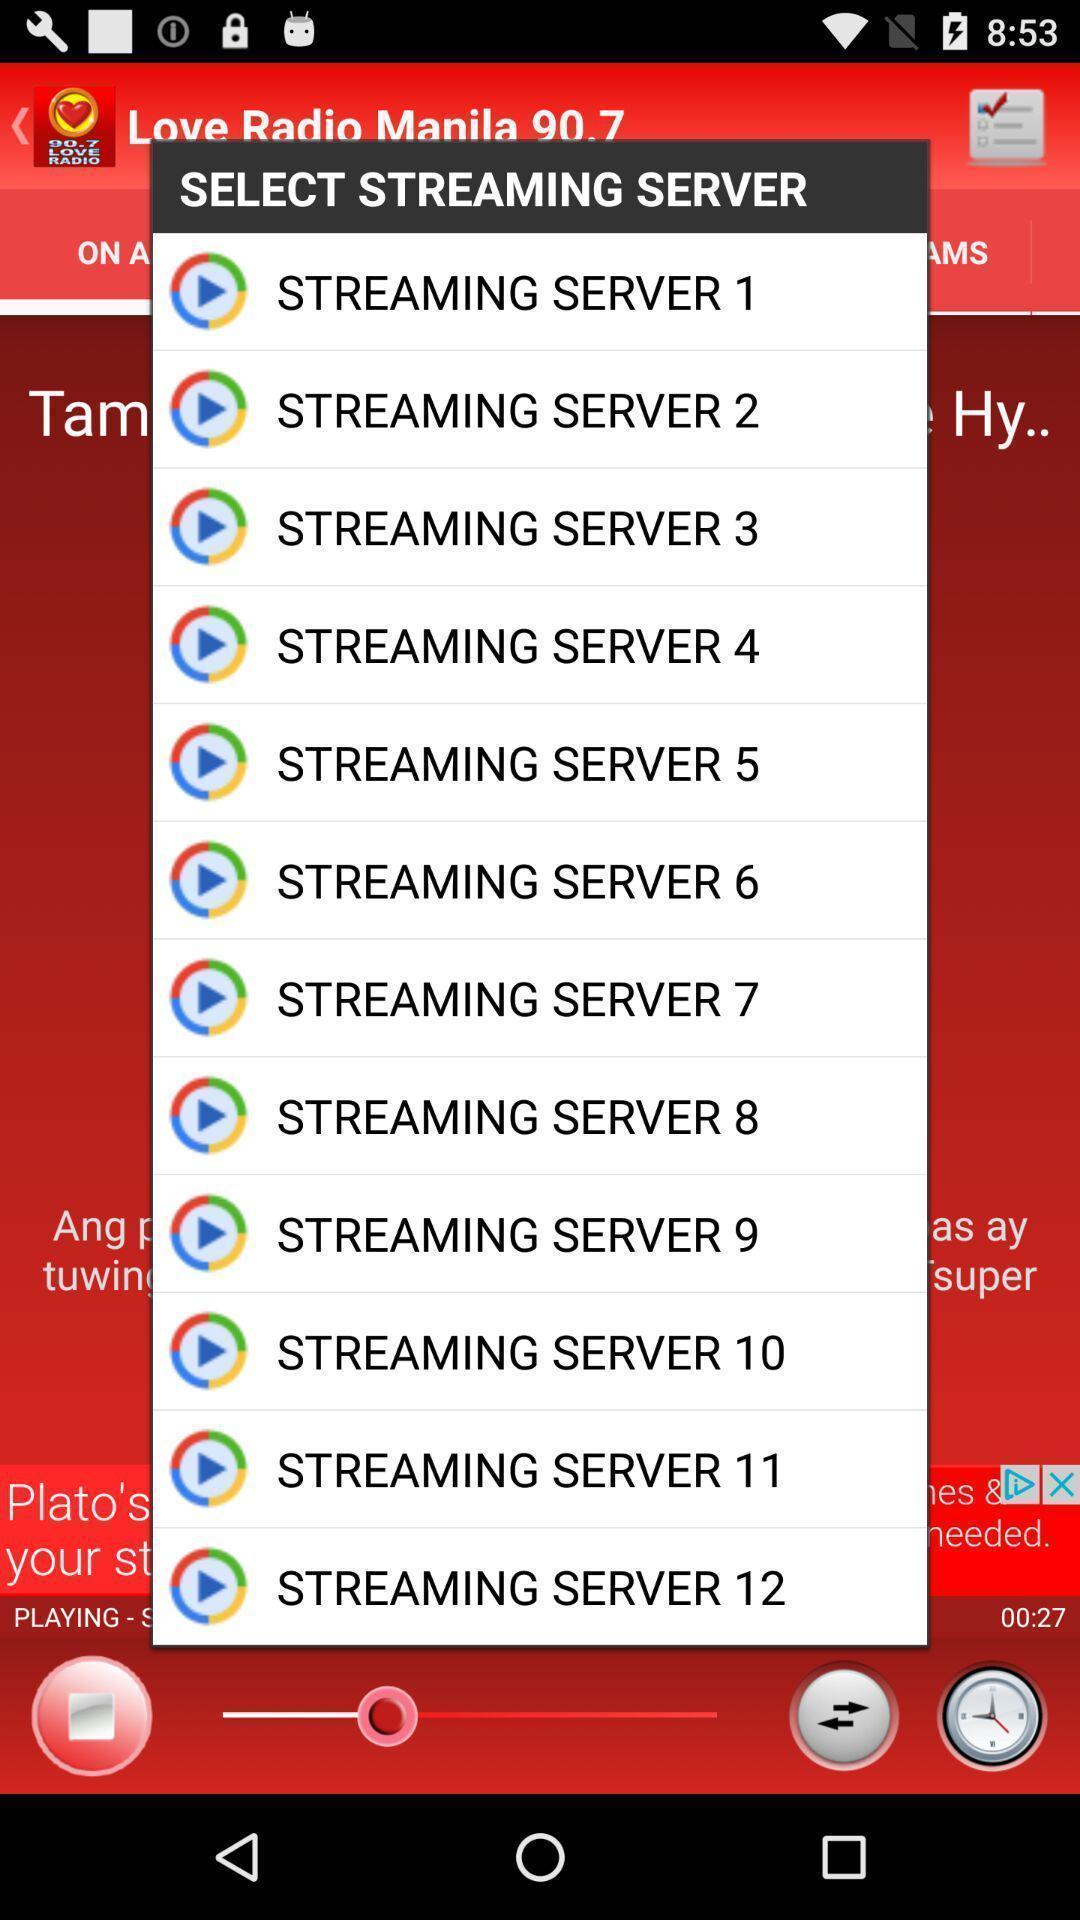Tell me what you see in this picture. Pop-up showing list of streaming servers to select. 